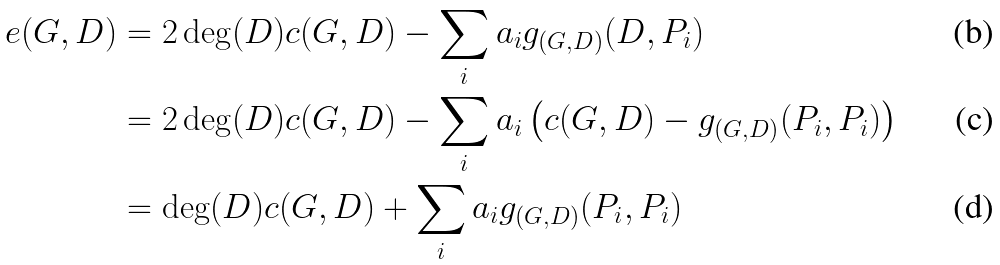Convert formula to latex. <formula><loc_0><loc_0><loc_500><loc_500>e ( G , D ) & = 2 \deg ( D ) c ( G , D ) - \sum _ { i } a _ { i } g _ { ( G , D ) } ( D , P _ { i } ) \\ & = 2 \deg ( D ) c ( G , D ) - \sum _ { i } a _ { i } \left ( c ( G , D ) - g _ { ( G , D ) } ( P _ { i } , P _ { i } ) \right ) \\ & = \deg ( D ) c ( G , D ) + \sum _ { i } a _ { i } g _ { ( G , D ) } ( P _ { i } , P _ { i } )</formula> 